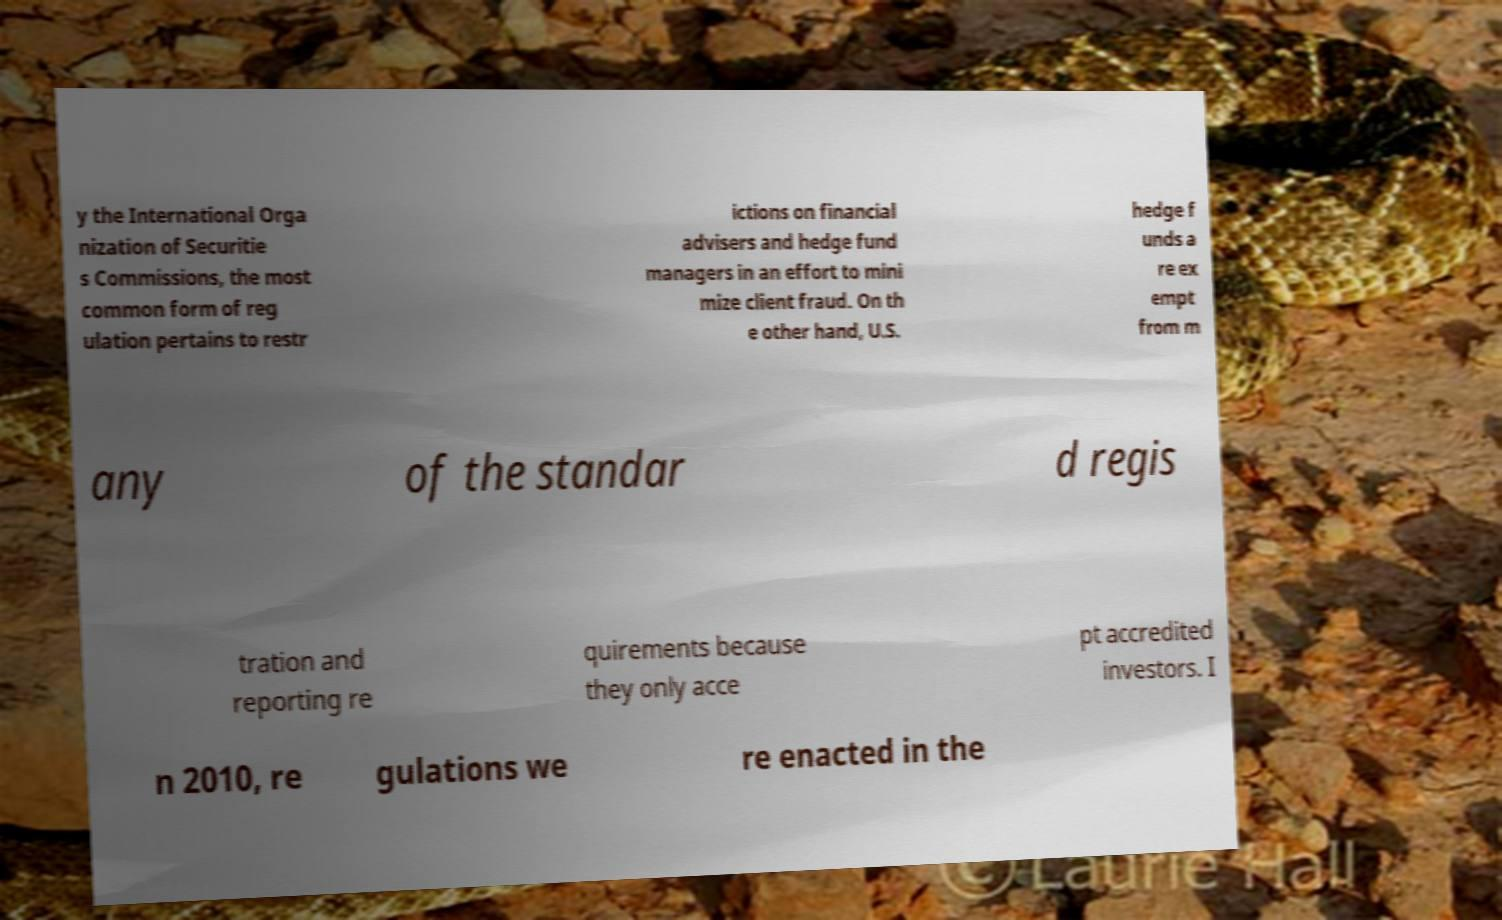Please identify and transcribe the text found in this image. y the International Orga nization of Securitie s Commissions, the most common form of reg ulation pertains to restr ictions on financial advisers and hedge fund managers in an effort to mini mize client fraud. On th e other hand, U.S. hedge f unds a re ex empt from m any of the standar d regis tration and reporting re quirements because they only acce pt accredited investors. I n 2010, re gulations we re enacted in the 